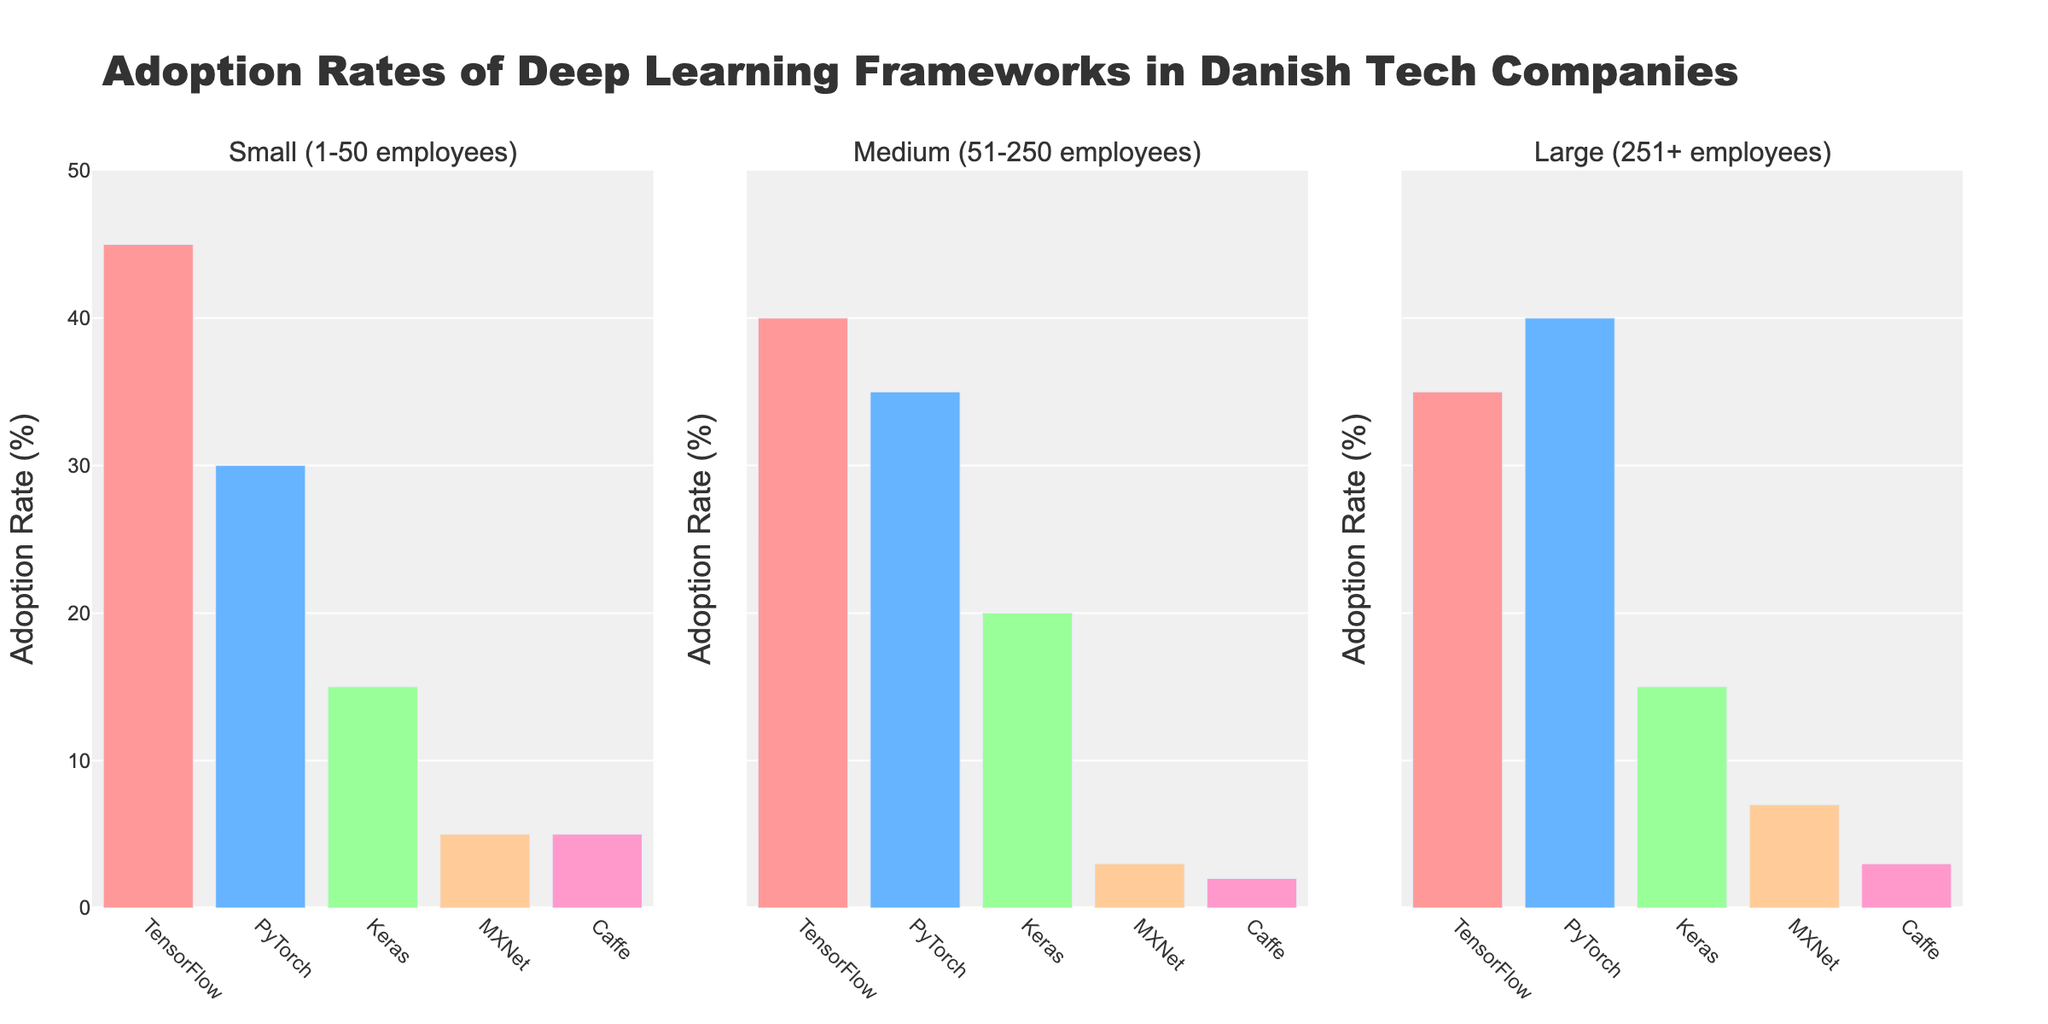How many company size categories are shown on the figure? The figure titles reveal three company size categories: "Small (1-50 employees)", "Medium (51-250 employees)", and "Large (251+ employees)".
Answer: 3 What is the title of the figure? The primary heading at the top of the figure specifies the overall topic: "Adoption Rates of Deep Learning Frameworks in Danish Tech Companies".
Answer: Adoption Rates of Deep Learning Frameworks in Danish Tech Companies Which framework has the highest adoption rate across all company sizes? Review the highest bars in each subplot. For small companies, TensorFlow leads with 45%. Medium companies show TensorFlow at 40%, and large companies favor PyTorch with 40%. Hence, TensorFlow takes the lead at 45% in small companies.
Answer: TensorFlow What is the total adoption rate of Keras in all company sizes? Sum the values from each subplot for Keras: 15% (small) + 20% (medium) + 15% (large). The total is 50%.
Answer: 50% Which framework is consistently the least adopted across all company sizes? Examine the smallest bars in all subplots. MXNet has 5%, 3%, and 7%, while Caffe has 5%, 2%, and 3%, respectively. Summing these gives MXNet: 15% and Caffe: 10%. Thus, Caffe is the least adopted.
Answer: Caffe Among the large companies, what is the difference in adoption rates between TensorFlow and PyTorch? In large companies, TensorFlow has a 35% adoption rate, whereas PyTorch has a 40% adoption rate. Their difference is 40% - 35% = 5%.
Answer: 5% What’s the average adoption rate of TensorFlow across all company sizes? Compute the average by summing TensorFlow rates: 45% (small) + 40% (medium) + 35% (large). Total = 120%. The average is 120% / 3 = 40%.
Answer: 40% What percentage more do medium-sized companies use PyTorch compared to small-sized companies? Medium companies have a 35% adoption rate, and small companies have 30% for PyTorch. The difference is 35% - 30% = 5%. Then, 5/30 * 100 = 16.67%.
Answer: 16.67% For large companies, what is the combined adoption rate of Caffe and MXNet? In large companies, Caffe has a 3% rate and MXNet 7%. Combined, it's 3% + 7% = 10%.
Answer: 10% Which company size category has the least usage of MXNet, and what is its percentage? Review the bars representing MXNet: small companies 5%, medium companies 3%, and large companies 7%. Hence, the medium-sized companies show the least usage at 3%.
Answer: Medium (51-250 employees), 3% 